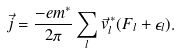<formula> <loc_0><loc_0><loc_500><loc_500>\vec { j } = \frac { - e m ^ { * } } { 2 \pi } \sum _ { l } \vec { v } _ { l } ^ { \, * } ( F _ { l } + \epsilon _ { l } ) .</formula> 